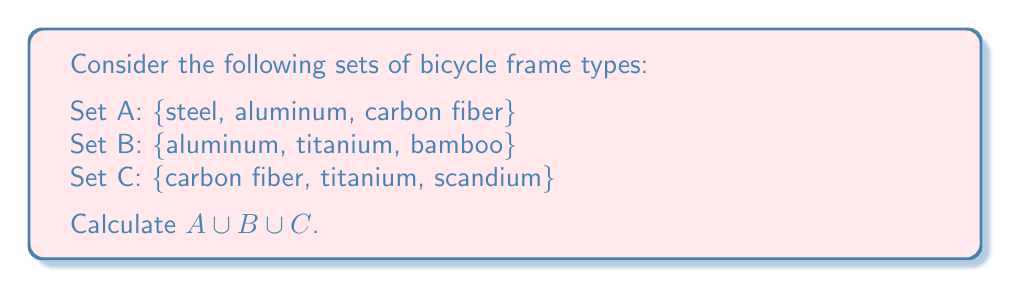Can you answer this question? To find the union of these three sets, we need to combine all unique elements from each set. Let's approach this step-by-step:

1) First, let's list out all elements from each set:
   A: steel, aluminum, carbon fiber
   B: aluminum, titanium, bamboo
   C: carbon fiber, titanium, scandium

2) Now, let's start building our union set by including all elements from set A:
   $A \cup B \cup C = \{$steel, aluminum, carbon fiber$\}$

3) Next, we add any elements from set B that are not already in our union set:
   - aluminum is already included
   - titanium is new, so we add it
   - bamboo is new, so we add it
   $A \cup B \cup C = \{$steel, aluminum, carbon fiber, titanium, bamboo$\}$

4) Finally, we add any elements from set C that are not already in our union set:
   - carbon fiber is already included
   - titanium is already included
   - scandium is new, so we add it
   $A \cup B \cup C = \{$steel, aluminum, carbon fiber, titanium, bamboo, scandium$\}$

5) We have now included all unique elements from all three sets.

Note that the order of elements in a set doesn't matter, so any arrangement of these six elements is equivalent.
Answer: $A \cup B \cup C = \{$steel, aluminum, carbon fiber, titanium, bamboo, scandium$\}$ 